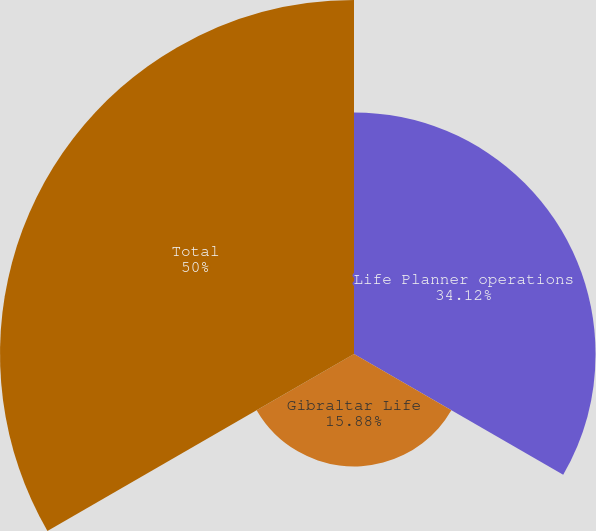Convert chart to OTSL. <chart><loc_0><loc_0><loc_500><loc_500><pie_chart><fcel>Life Planner operations<fcel>Gibraltar Life<fcel>Total<nl><fcel>34.12%<fcel>15.88%<fcel>50.0%<nl></chart> 